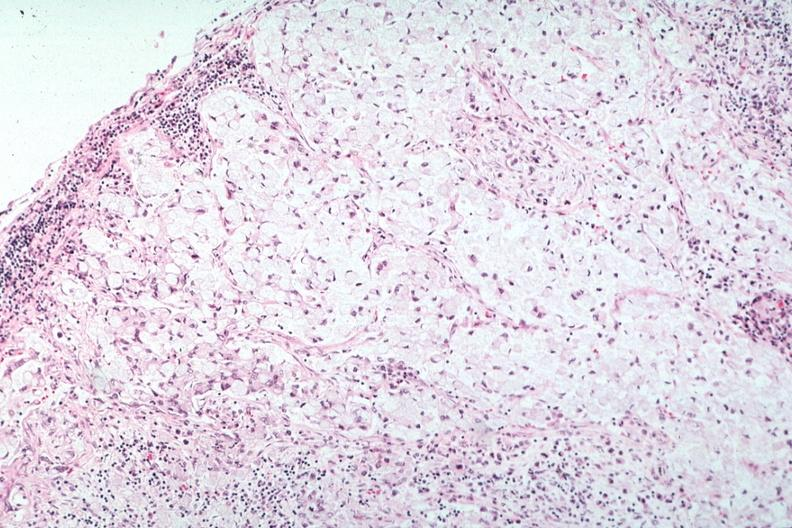what is present?
Answer the question using a single word or phrase. Metastatic carcinoma 